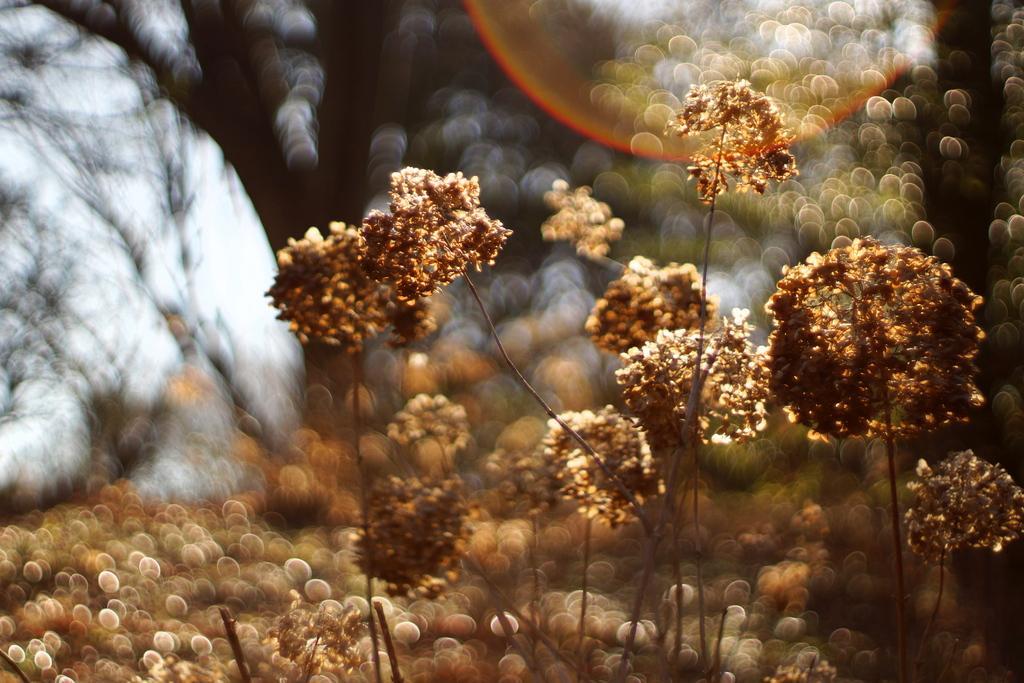Can you describe this image briefly? In this image in the front there are plants and the background is blurry. 